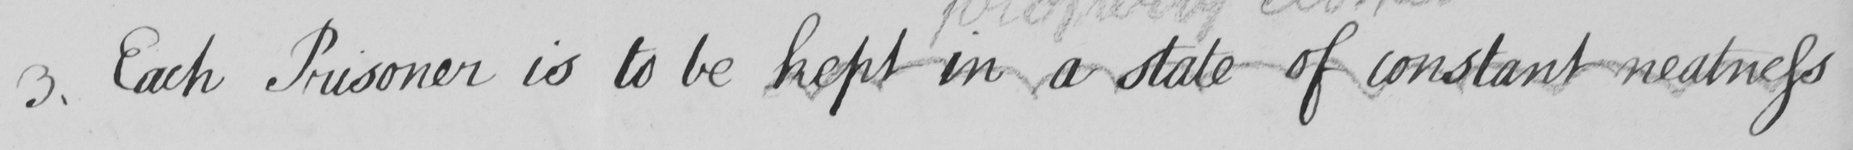Please transcribe the handwritten text in this image. 3 . Each Prisoner is to be kept in a state of constant neatness 